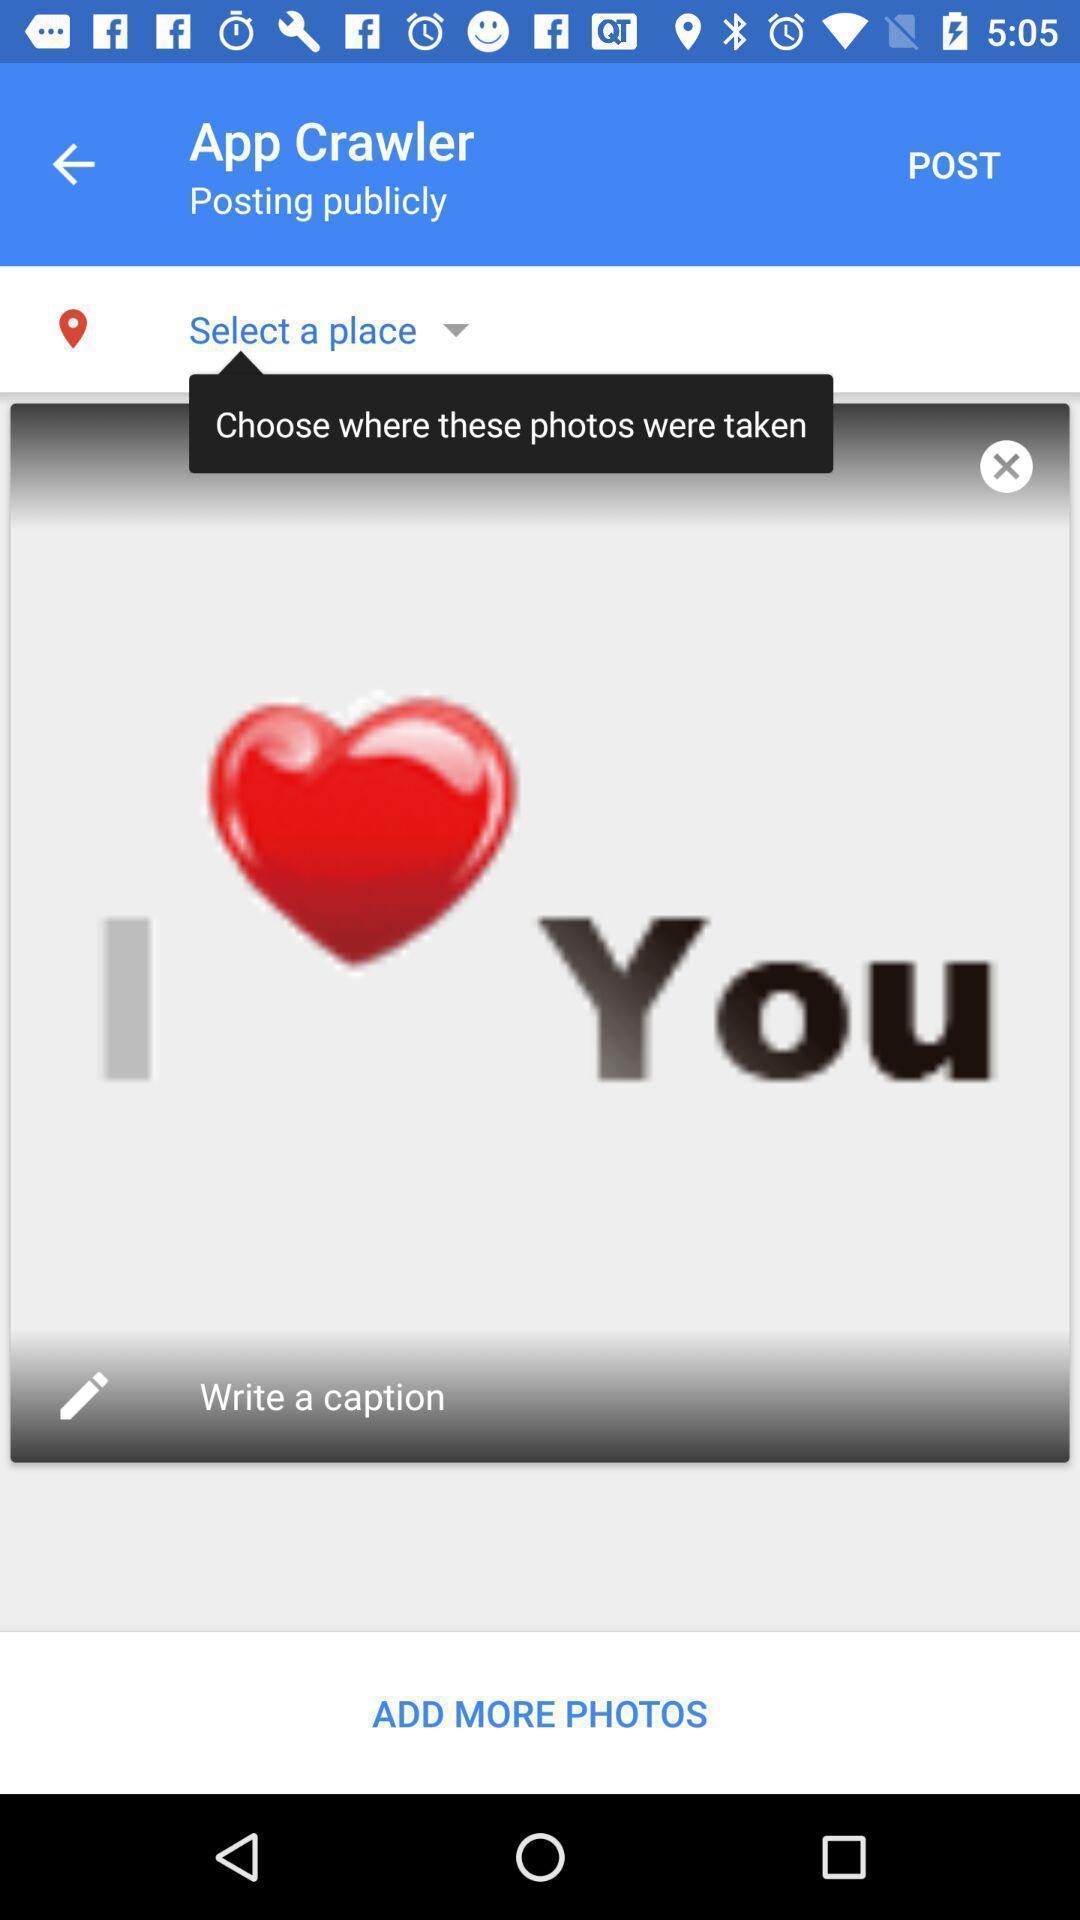Explain the elements present in this screenshot. Screen shows image post on a social app. 